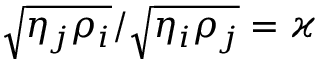Convert formula to latex. <formula><loc_0><loc_0><loc_500><loc_500>\sqrt { \eta _ { j } \rho _ { i } } / \sqrt { \eta _ { i } \rho _ { j } } = \varkappa</formula> 